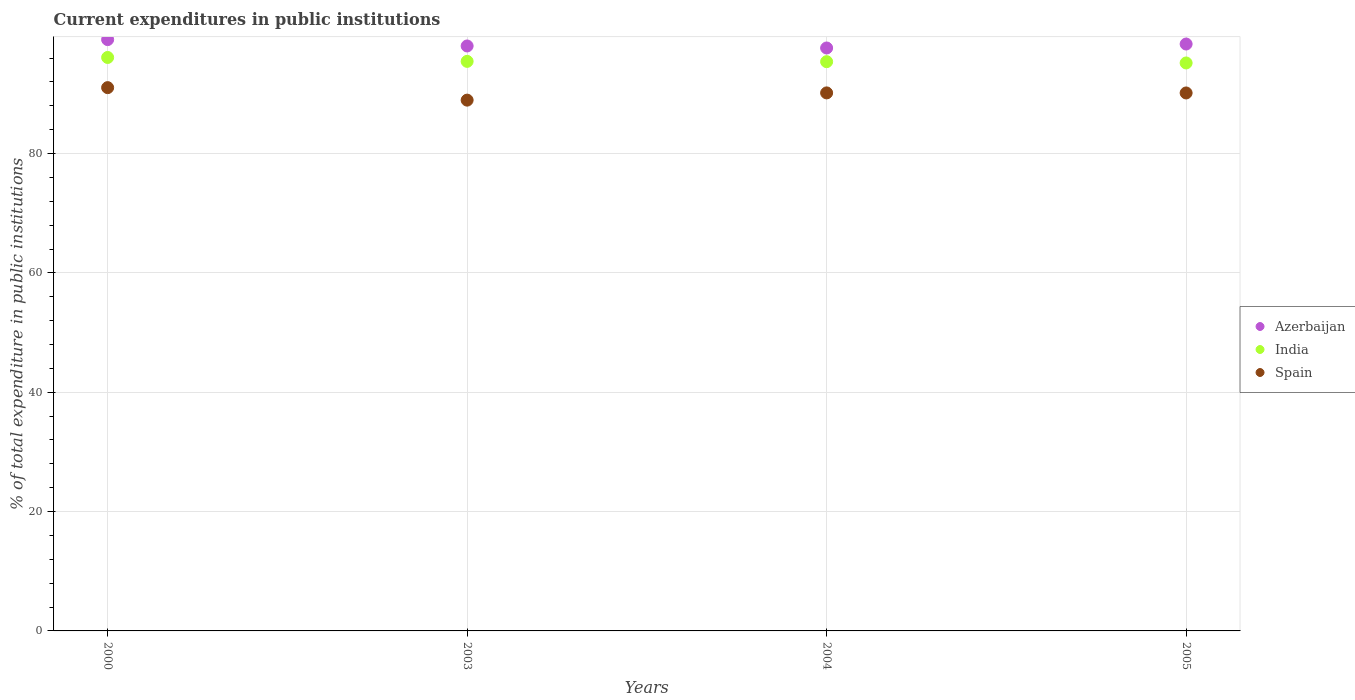Is the number of dotlines equal to the number of legend labels?
Give a very brief answer. Yes. What is the current expenditures in public institutions in India in 2000?
Provide a succinct answer. 96.11. Across all years, what is the maximum current expenditures in public institutions in India?
Your answer should be very brief. 96.11. Across all years, what is the minimum current expenditures in public institutions in Spain?
Your response must be concise. 88.96. In which year was the current expenditures in public institutions in India minimum?
Your response must be concise. 2005. What is the total current expenditures in public institutions in Azerbaijan in the graph?
Offer a terse response. 393.19. What is the difference between the current expenditures in public institutions in Azerbaijan in 2000 and that in 2003?
Keep it short and to the point. 1.07. What is the difference between the current expenditures in public institutions in India in 2003 and the current expenditures in public institutions in Azerbaijan in 2000?
Give a very brief answer. -3.65. What is the average current expenditures in public institutions in Spain per year?
Keep it short and to the point. 90.08. In the year 2000, what is the difference between the current expenditures in public institutions in Spain and current expenditures in public institutions in India?
Give a very brief answer. -5.06. What is the ratio of the current expenditures in public institutions in India in 2000 to that in 2005?
Your answer should be very brief. 1.01. Is the difference between the current expenditures in public institutions in Spain in 2003 and 2005 greater than the difference between the current expenditures in public institutions in India in 2003 and 2005?
Provide a succinct answer. No. What is the difference between the highest and the second highest current expenditures in public institutions in Spain?
Your answer should be compact. 0.88. What is the difference between the highest and the lowest current expenditures in public institutions in India?
Provide a succinct answer. 0.92. In how many years, is the current expenditures in public institutions in Spain greater than the average current expenditures in public institutions in Spain taken over all years?
Your answer should be compact. 3. Is the sum of the current expenditures in public institutions in Spain in 2003 and 2005 greater than the maximum current expenditures in public institutions in Azerbaijan across all years?
Your response must be concise. Yes. Does the current expenditures in public institutions in Spain monotonically increase over the years?
Make the answer very short. No. How many years are there in the graph?
Your answer should be compact. 4. What is the difference between two consecutive major ticks on the Y-axis?
Offer a very short reply. 20. Are the values on the major ticks of Y-axis written in scientific E-notation?
Your response must be concise. No. Does the graph contain any zero values?
Keep it short and to the point. No. Does the graph contain grids?
Your response must be concise. Yes. How are the legend labels stacked?
Ensure brevity in your answer.  Vertical. What is the title of the graph?
Your response must be concise. Current expenditures in public institutions. Does "American Samoa" appear as one of the legend labels in the graph?
Make the answer very short. No. What is the label or title of the Y-axis?
Offer a terse response. % of total expenditure in public institutions. What is the % of total expenditure in public institutions in Azerbaijan in 2000?
Your answer should be very brief. 99.1. What is the % of total expenditure in public institutions in India in 2000?
Your answer should be very brief. 96.11. What is the % of total expenditure in public institutions of Spain in 2000?
Offer a terse response. 91.05. What is the % of total expenditure in public institutions of Azerbaijan in 2003?
Your response must be concise. 98.03. What is the % of total expenditure in public institutions in India in 2003?
Make the answer very short. 95.45. What is the % of total expenditure in public institutions of Spain in 2003?
Ensure brevity in your answer.  88.96. What is the % of total expenditure in public institutions in Azerbaijan in 2004?
Keep it short and to the point. 97.7. What is the % of total expenditure in public institutions of India in 2004?
Ensure brevity in your answer.  95.4. What is the % of total expenditure in public institutions of Spain in 2004?
Your answer should be compact. 90.17. What is the % of total expenditure in public institutions in Azerbaijan in 2005?
Your answer should be compact. 98.36. What is the % of total expenditure in public institutions of India in 2005?
Ensure brevity in your answer.  95.19. What is the % of total expenditure in public institutions of Spain in 2005?
Make the answer very short. 90.16. Across all years, what is the maximum % of total expenditure in public institutions in Azerbaijan?
Offer a very short reply. 99.1. Across all years, what is the maximum % of total expenditure in public institutions of India?
Make the answer very short. 96.11. Across all years, what is the maximum % of total expenditure in public institutions in Spain?
Ensure brevity in your answer.  91.05. Across all years, what is the minimum % of total expenditure in public institutions in Azerbaijan?
Make the answer very short. 97.7. Across all years, what is the minimum % of total expenditure in public institutions in India?
Keep it short and to the point. 95.19. Across all years, what is the minimum % of total expenditure in public institutions in Spain?
Give a very brief answer. 88.96. What is the total % of total expenditure in public institutions of Azerbaijan in the graph?
Provide a short and direct response. 393.19. What is the total % of total expenditure in public institutions in India in the graph?
Your answer should be very brief. 382.14. What is the total % of total expenditure in public institutions in Spain in the graph?
Make the answer very short. 360.33. What is the difference between the % of total expenditure in public institutions of Azerbaijan in 2000 and that in 2003?
Your answer should be compact. 1.07. What is the difference between the % of total expenditure in public institutions in India in 2000 and that in 2003?
Keep it short and to the point. 0.65. What is the difference between the % of total expenditure in public institutions in Spain in 2000 and that in 2003?
Your response must be concise. 2.09. What is the difference between the % of total expenditure in public institutions of Azerbaijan in 2000 and that in 2004?
Your answer should be very brief. 1.41. What is the difference between the % of total expenditure in public institutions of India in 2000 and that in 2004?
Keep it short and to the point. 0.71. What is the difference between the % of total expenditure in public institutions of Spain in 2000 and that in 2004?
Provide a succinct answer. 0.88. What is the difference between the % of total expenditure in public institutions of Azerbaijan in 2000 and that in 2005?
Give a very brief answer. 0.74. What is the difference between the % of total expenditure in public institutions of India in 2000 and that in 2005?
Offer a very short reply. 0.92. What is the difference between the % of total expenditure in public institutions of Spain in 2000 and that in 2005?
Give a very brief answer. 0.89. What is the difference between the % of total expenditure in public institutions of Azerbaijan in 2003 and that in 2004?
Offer a terse response. 0.34. What is the difference between the % of total expenditure in public institutions of India in 2003 and that in 2004?
Offer a very short reply. 0.05. What is the difference between the % of total expenditure in public institutions of Spain in 2003 and that in 2004?
Provide a succinct answer. -1.21. What is the difference between the % of total expenditure in public institutions in Azerbaijan in 2003 and that in 2005?
Provide a succinct answer. -0.33. What is the difference between the % of total expenditure in public institutions in India in 2003 and that in 2005?
Your answer should be compact. 0.27. What is the difference between the % of total expenditure in public institutions of Spain in 2003 and that in 2005?
Ensure brevity in your answer.  -1.2. What is the difference between the % of total expenditure in public institutions of Azerbaijan in 2004 and that in 2005?
Ensure brevity in your answer.  -0.66. What is the difference between the % of total expenditure in public institutions in India in 2004 and that in 2005?
Keep it short and to the point. 0.22. What is the difference between the % of total expenditure in public institutions in Spain in 2004 and that in 2005?
Keep it short and to the point. 0.01. What is the difference between the % of total expenditure in public institutions of Azerbaijan in 2000 and the % of total expenditure in public institutions of India in 2003?
Offer a terse response. 3.65. What is the difference between the % of total expenditure in public institutions in Azerbaijan in 2000 and the % of total expenditure in public institutions in Spain in 2003?
Offer a terse response. 10.14. What is the difference between the % of total expenditure in public institutions of India in 2000 and the % of total expenditure in public institutions of Spain in 2003?
Give a very brief answer. 7.15. What is the difference between the % of total expenditure in public institutions in Azerbaijan in 2000 and the % of total expenditure in public institutions in India in 2004?
Provide a succinct answer. 3.7. What is the difference between the % of total expenditure in public institutions in Azerbaijan in 2000 and the % of total expenditure in public institutions in Spain in 2004?
Give a very brief answer. 8.93. What is the difference between the % of total expenditure in public institutions of India in 2000 and the % of total expenditure in public institutions of Spain in 2004?
Make the answer very short. 5.94. What is the difference between the % of total expenditure in public institutions in Azerbaijan in 2000 and the % of total expenditure in public institutions in India in 2005?
Your response must be concise. 3.92. What is the difference between the % of total expenditure in public institutions of Azerbaijan in 2000 and the % of total expenditure in public institutions of Spain in 2005?
Ensure brevity in your answer.  8.94. What is the difference between the % of total expenditure in public institutions in India in 2000 and the % of total expenditure in public institutions in Spain in 2005?
Your response must be concise. 5.95. What is the difference between the % of total expenditure in public institutions in Azerbaijan in 2003 and the % of total expenditure in public institutions in India in 2004?
Keep it short and to the point. 2.63. What is the difference between the % of total expenditure in public institutions in Azerbaijan in 2003 and the % of total expenditure in public institutions in Spain in 2004?
Offer a terse response. 7.87. What is the difference between the % of total expenditure in public institutions of India in 2003 and the % of total expenditure in public institutions of Spain in 2004?
Offer a very short reply. 5.28. What is the difference between the % of total expenditure in public institutions of Azerbaijan in 2003 and the % of total expenditure in public institutions of India in 2005?
Offer a terse response. 2.85. What is the difference between the % of total expenditure in public institutions of Azerbaijan in 2003 and the % of total expenditure in public institutions of Spain in 2005?
Your response must be concise. 7.88. What is the difference between the % of total expenditure in public institutions of India in 2003 and the % of total expenditure in public institutions of Spain in 2005?
Offer a terse response. 5.29. What is the difference between the % of total expenditure in public institutions in Azerbaijan in 2004 and the % of total expenditure in public institutions in India in 2005?
Your response must be concise. 2.51. What is the difference between the % of total expenditure in public institutions in Azerbaijan in 2004 and the % of total expenditure in public institutions in Spain in 2005?
Provide a succinct answer. 7.54. What is the difference between the % of total expenditure in public institutions in India in 2004 and the % of total expenditure in public institutions in Spain in 2005?
Keep it short and to the point. 5.24. What is the average % of total expenditure in public institutions of Azerbaijan per year?
Your response must be concise. 98.3. What is the average % of total expenditure in public institutions of India per year?
Offer a terse response. 95.54. What is the average % of total expenditure in public institutions of Spain per year?
Give a very brief answer. 90.08. In the year 2000, what is the difference between the % of total expenditure in public institutions of Azerbaijan and % of total expenditure in public institutions of India?
Your answer should be compact. 2.99. In the year 2000, what is the difference between the % of total expenditure in public institutions in Azerbaijan and % of total expenditure in public institutions in Spain?
Make the answer very short. 8.05. In the year 2000, what is the difference between the % of total expenditure in public institutions in India and % of total expenditure in public institutions in Spain?
Offer a terse response. 5.06. In the year 2003, what is the difference between the % of total expenditure in public institutions of Azerbaijan and % of total expenditure in public institutions of India?
Your answer should be compact. 2.58. In the year 2003, what is the difference between the % of total expenditure in public institutions of Azerbaijan and % of total expenditure in public institutions of Spain?
Your response must be concise. 9.08. In the year 2003, what is the difference between the % of total expenditure in public institutions of India and % of total expenditure in public institutions of Spain?
Your response must be concise. 6.5. In the year 2004, what is the difference between the % of total expenditure in public institutions of Azerbaijan and % of total expenditure in public institutions of India?
Your answer should be compact. 2.29. In the year 2004, what is the difference between the % of total expenditure in public institutions in Azerbaijan and % of total expenditure in public institutions in Spain?
Keep it short and to the point. 7.53. In the year 2004, what is the difference between the % of total expenditure in public institutions in India and % of total expenditure in public institutions in Spain?
Your response must be concise. 5.23. In the year 2005, what is the difference between the % of total expenditure in public institutions of Azerbaijan and % of total expenditure in public institutions of India?
Offer a very short reply. 3.17. In the year 2005, what is the difference between the % of total expenditure in public institutions of Azerbaijan and % of total expenditure in public institutions of Spain?
Your response must be concise. 8.2. In the year 2005, what is the difference between the % of total expenditure in public institutions in India and % of total expenditure in public institutions in Spain?
Provide a succinct answer. 5.03. What is the ratio of the % of total expenditure in public institutions of Azerbaijan in 2000 to that in 2003?
Make the answer very short. 1.01. What is the ratio of the % of total expenditure in public institutions in Spain in 2000 to that in 2003?
Your response must be concise. 1.02. What is the ratio of the % of total expenditure in public institutions of Azerbaijan in 2000 to that in 2004?
Your response must be concise. 1.01. What is the ratio of the % of total expenditure in public institutions in India in 2000 to that in 2004?
Offer a very short reply. 1.01. What is the ratio of the % of total expenditure in public institutions in Spain in 2000 to that in 2004?
Ensure brevity in your answer.  1.01. What is the ratio of the % of total expenditure in public institutions in Azerbaijan in 2000 to that in 2005?
Provide a succinct answer. 1.01. What is the ratio of the % of total expenditure in public institutions of India in 2000 to that in 2005?
Offer a terse response. 1.01. What is the ratio of the % of total expenditure in public institutions in Spain in 2000 to that in 2005?
Give a very brief answer. 1.01. What is the ratio of the % of total expenditure in public institutions in Azerbaijan in 2003 to that in 2004?
Make the answer very short. 1. What is the ratio of the % of total expenditure in public institutions in India in 2003 to that in 2004?
Keep it short and to the point. 1. What is the ratio of the % of total expenditure in public institutions of Spain in 2003 to that in 2004?
Provide a short and direct response. 0.99. What is the ratio of the % of total expenditure in public institutions in Spain in 2003 to that in 2005?
Provide a short and direct response. 0.99. What is the difference between the highest and the second highest % of total expenditure in public institutions in Azerbaijan?
Provide a short and direct response. 0.74. What is the difference between the highest and the second highest % of total expenditure in public institutions in India?
Keep it short and to the point. 0.65. What is the difference between the highest and the second highest % of total expenditure in public institutions in Spain?
Ensure brevity in your answer.  0.88. What is the difference between the highest and the lowest % of total expenditure in public institutions of Azerbaijan?
Give a very brief answer. 1.41. What is the difference between the highest and the lowest % of total expenditure in public institutions of India?
Provide a succinct answer. 0.92. What is the difference between the highest and the lowest % of total expenditure in public institutions in Spain?
Provide a short and direct response. 2.09. 